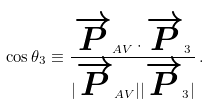<formula> <loc_0><loc_0><loc_500><loc_500>\cos \theta _ { 3 } \equiv \frac { \overrightarrow { P } _ { A V } \cdot \overrightarrow { P } _ { 3 } } { | \overrightarrow { P } _ { A V } | | \overrightarrow { P } _ { 3 } | } \, . \\</formula> 